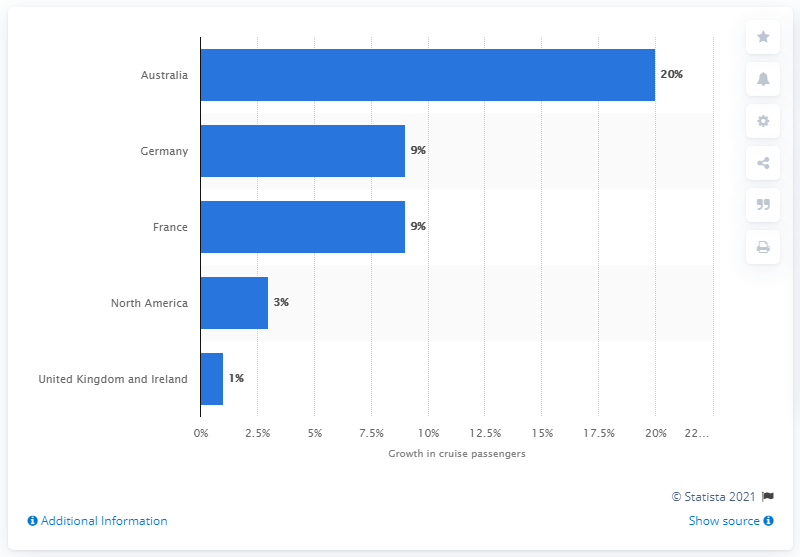Which country is shown as having the second-highest growth in cruise passengers according to this graph? Germany and France are shown as having the second-highest growth in cruise passengers, each with 9%, according to the bar graph. 